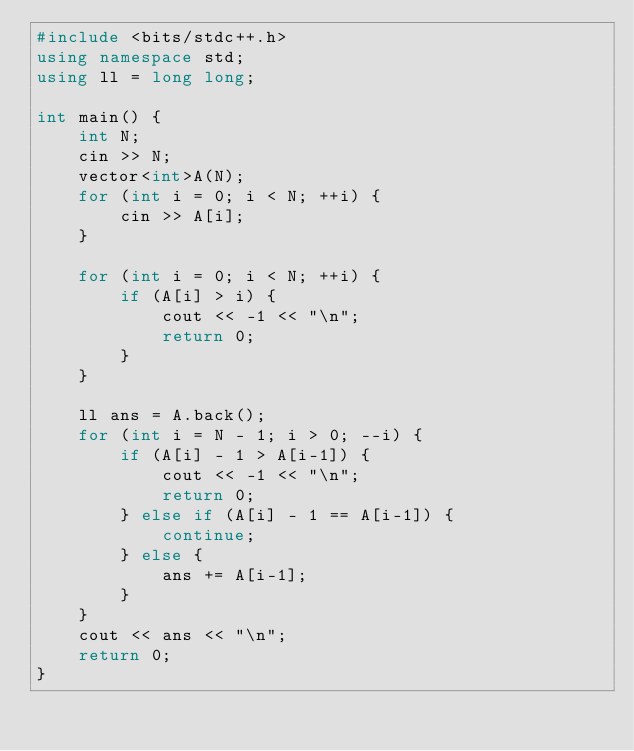Convert code to text. <code><loc_0><loc_0><loc_500><loc_500><_C++_>#include <bits/stdc++.h>
using namespace std;
using ll = long long;

int main() {
    int N;
    cin >> N;
    vector<int>A(N);
    for (int i = 0; i < N; ++i) {
        cin >> A[i];
    }

    for (int i = 0; i < N; ++i) {
        if (A[i] > i) {
            cout << -1 << "\n";
            return 0;
        }
    }

    ll ans = A.back();
    for (int i = N - 1; i > 0; --i) {
        if (A[i] - 1 > A[i-1]) {
            cout << -1 << "\n";
            return 0;
        } else if (A[i] - 1 == A[i-1]) {
            continue;
        } else {
            ans += A[i-1];
        }
    }
    cout << ans << "\n";
    return 0;
}</code> 